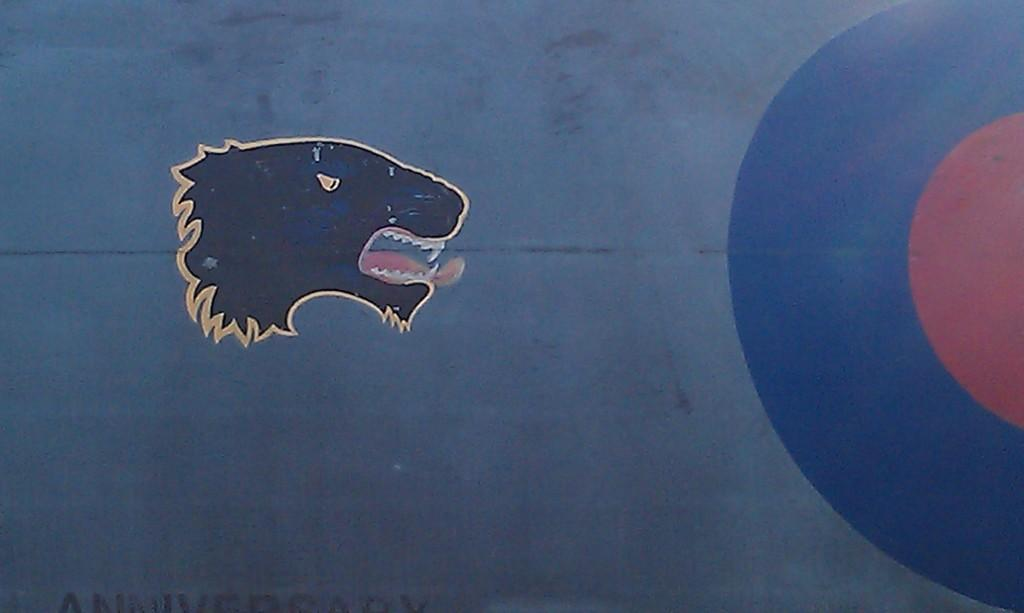What is the main subject of the painting in the image? There is a painting of an animal's face in the image. What type of soda is being advertised on the calendar in the image? There is no soda or calendar present in the image; it only features a painting of an animal's face. 